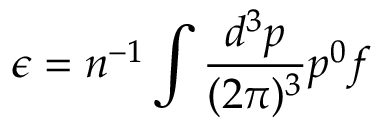Convert formula to latex. <formula><loc_0><loc_0><loc_500><loc_500>\epsilon = n ^ { - 1 } \int \frac { d ^ { 3 } p } { ( 2 \pi ) ^ { 3 } } p ^ { 0 } f</formula> 